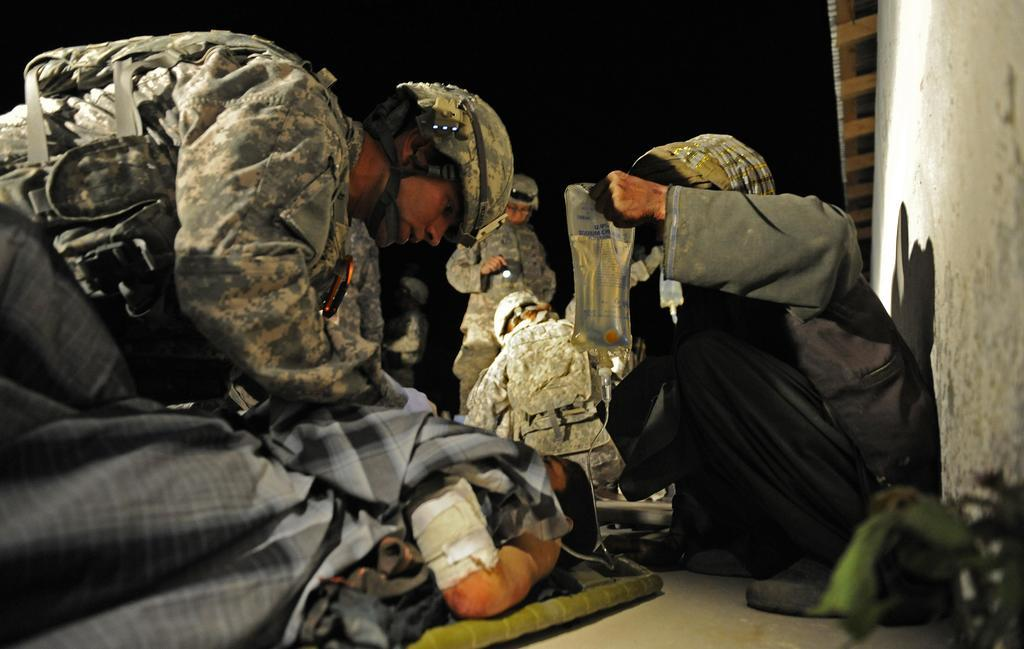What type of people can be seen in the image? There are army people in the image. What are the army people holding in their hands? The army people are holding objects. Can you describe the structure visible in the background of the image? There is a wall with a roof visible in the image. What type of eggnog is being served to the army people in the image? There is no eggnog present in the image. 